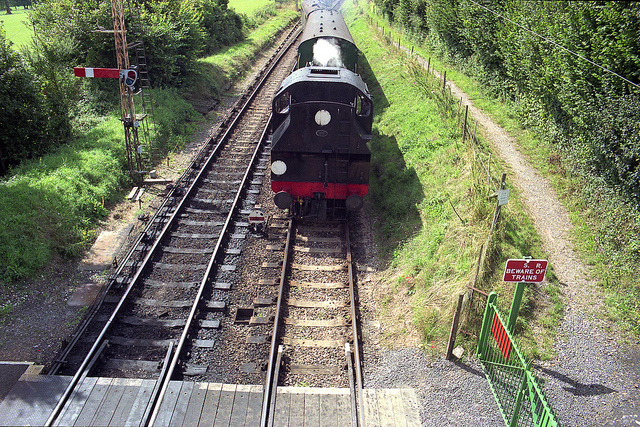<image>What does the sign say? I am not certain what the sign says. However, it could read 'stop', 'beware of trains', 'stay off tracks', or 'delaware'. What does the sign say? I am not sure what the sign says. It can be seen "stop", "beware of trains", "stay off tracks", or "delaware". 